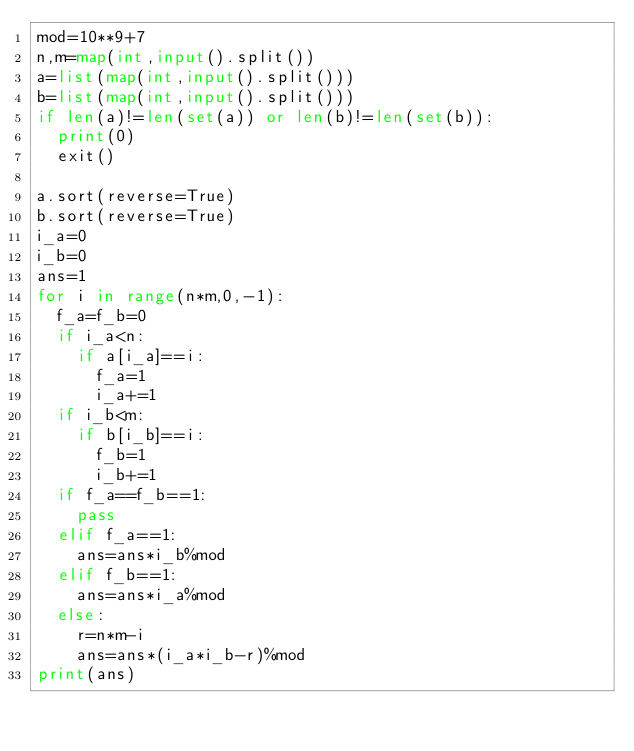Convert code to text. <code><loc_0><loc_0><loc_500><loc_500><_Python_>mod=10**9+7
n,m=map(int,input().split())
a=list(map(int,input().split()))
b=list(map(int,input().split()))
if len(a)!=len(set(a)) or len(b)!=len(set(b)):
	print(0)
	exit()

a.sort(reverse=True)
b.sort(reverse=True)
i_a=0
i_b=0
ans=1
for i in range(n*m,0,-1):
	f_a=f_b=0
	if i_a<n:
		if a[i_a]==i:
			f_a=1
			i_a+=1
	if i_b<m:
		if b[i_b]==i:
			f_b=1
			i_b+=1
	if f_a==f_b==1:
		pass
	elif f_a==1:
		ans=ans*i_b%mod
	elif f_b==1:
		ans=ans*i_a%mod
	else:
		r=n*m-i
		ans=ans*(i_a*i_b-r)%mod
print(ans)</code> 